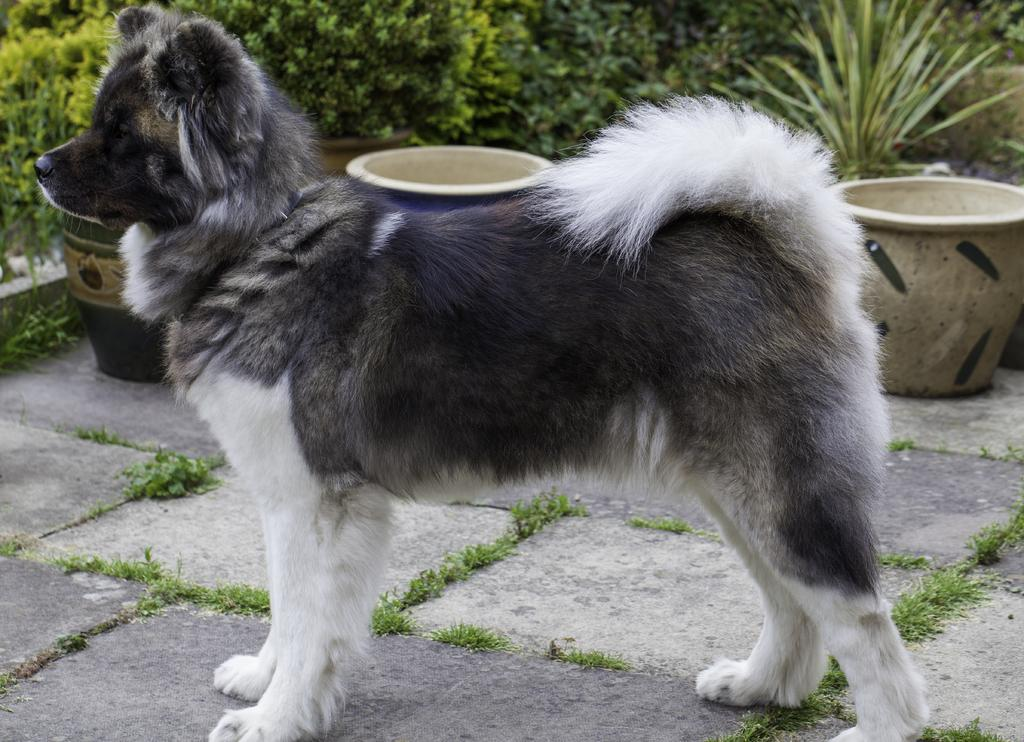What animal is present in the image? There is a dog in the image. What color is the dog in the image? The dog is in black and white color. What is visible at the bottom of the image? There is ground at the bottom of the image. What type of vegetation can be seen in the background of the image? There are plants in the background of the image. What type of story is being told by the dog on the swing in the image? There is no dog on a swing in the image, nor is there any story being told. 